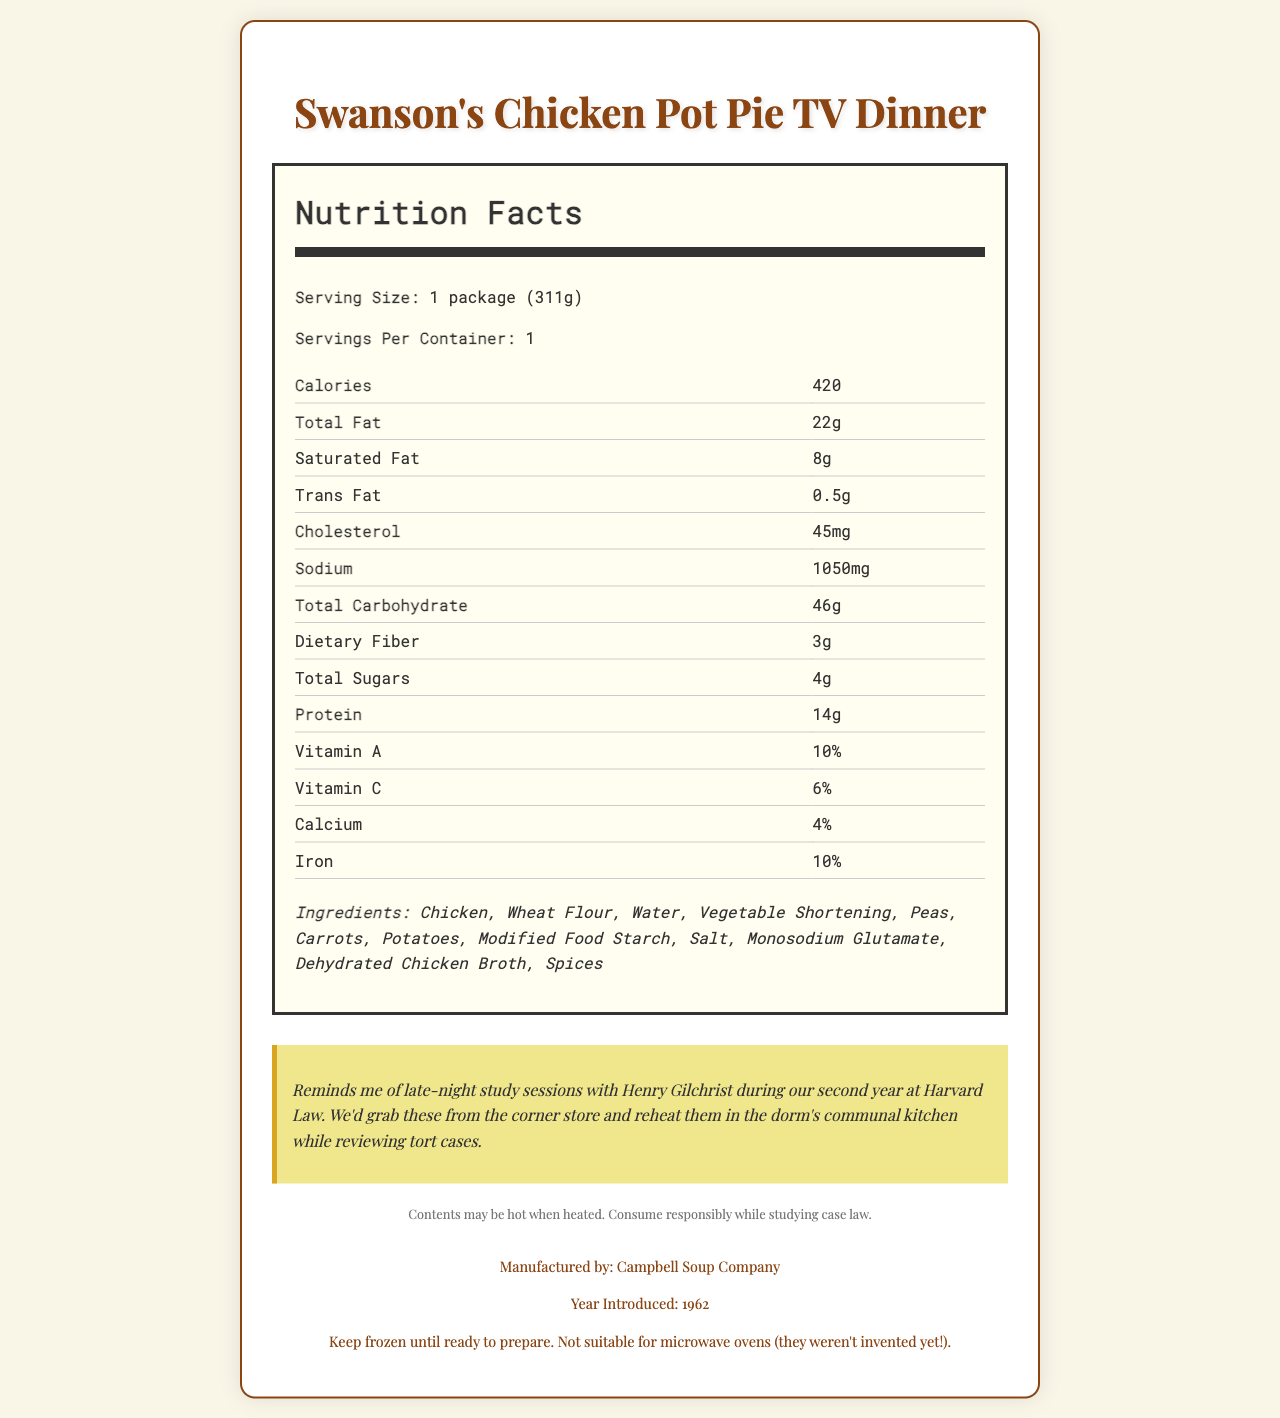what is the serving size of Swanson's Chicken Pot Pie TV Dinner? The serving size is listed under the nutrition facts section as "1 package (311g)".
Answer: 1 package (311g) how much total fat does one serving contain? The nutrition facts section specifies that the total fat content is 22g per serving.
Answer: 22g how many calories are in one serving of this TV dinner? The document lists calories as 420.
Answer: 420 what percentage of daily Vitamin A is provided by one serving? The nutrition facts indicate that one serving provides 10% of the daily value for Vitamin A.
Answer: 10% which company manufactures Swanson's Chicken Pot Pie TV Dinner? The footer of the document states that it is manufactured by Campbell Soup Company.
Answer: Campbell Soup Company how much cholesterol is in one serving? The nutrition facts list the amount of cholesterol as 45mg per serving.
Answer: 45mg how many grams of protein are in one serving of this TV dinner? The nutrition facts section states that there are 14g of protein in one serving.
Answer: 14g how long before microwaves became popular was this TV dinner introduced? The document indicates that this product was introduced in 1962, an era before microwave ovens became commonly used.
Answer: 1962 which of the following is NOT an ingredient in Swanson's Chicken Pot Pie TV Dinner? A. Chicken B. Wheat Flour C. Modified Food Starch D. Tuna The ingredients listed are Chicken, Wheat Flour, Modified Food Starch, etc., and Tuna is not among them.
Answer: D how much sodium is in one serving? The nutrition facts section lists the sodium content as 1050mg.
Answer: 1050mg True or False: This TV dinner contains trans fat. The document indicates that the TV dinner contains 0.5g of trans fat.
Answer: True Does the product contain any fiber? If so, how much? The document lists "Dietary Fiber" as 3g in the nutrition facts section.
Answer: 3g summarize the entire document in one sentence. This one-sentence summary captures the essence of the document, highlighting its purpose and content.
Answer: The document is a nostalgic nutrition facts label for Swanson's Chicken Pot Pie TV Dinner, providing detailed nutritional information, ingredients, a nostalgic note about law school, and manufacturing details. what is the main message in the nostalgic note? The nostalgic note explicitly mentions the memories of study sessions and the shared experiences with Henry.
Answer: The nostalgic note reminisces about late-night study sessions at Harvard Law with Henry Gilchrist while enjoying this TV dinner. is the TV dinner suitable for microwave ovens? The storage instructions explicitly state that this product is not suitable for microwave ovens as they weren't yet invented.
Answer: No when was Swanson's Chicken Pot Pie TV Dinner introduced? The footer of the document indicates that the product was introduced in 1962.
Answer: 1962 how should the TV dinner be stored? The storage instructions specify that the TV dinner should be kept frozen until prepared.
Answer: Keep frozen until ready to prepare. why might it not be suitable to assume all classic TV dinners from the 1960s had the same nutritional content? The document provides nutritional information for only one specific TV dinner, so assumptions about other products cannot be made.
Answer: Cannot be determined how much calcium does one serving provide as a percentage of the daily value? The nutrition facts section states that one serving provides 4% of the daily value for calcium.
Answer: 4% in what type of container should Swanson's Chicken Pot Pie TV Dinner be kept until ready to prepare? The storage instructions mention to "Keep frozen until ready to prepare."
Answer: Frozen container 